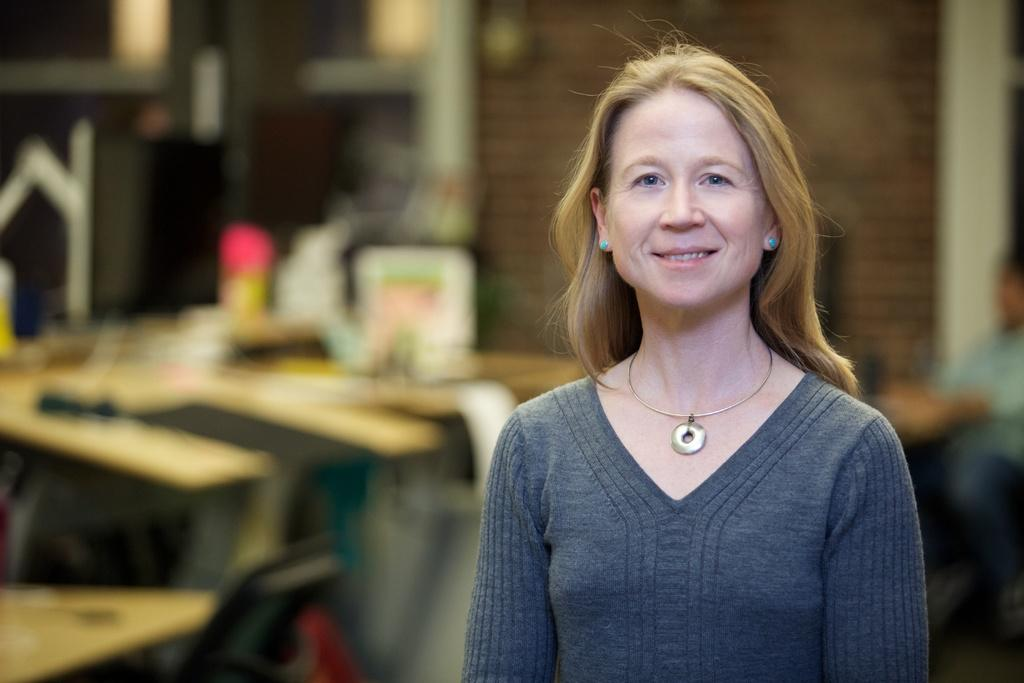Who is the main subject in the image? There is a woman in the image. What is the woman wearing? The woman is wearing clothes, a neck chain, and ear studs. What is the woman's facial expression? The woman is smiling. How would you describe the background of the image? The background of the image is blurred. How many apples can be seen in the woman's hand in the image? There are no apples present in the image. What type of motion is the woman performing in the image? The image does not depict any motion; the woman is standing still. 